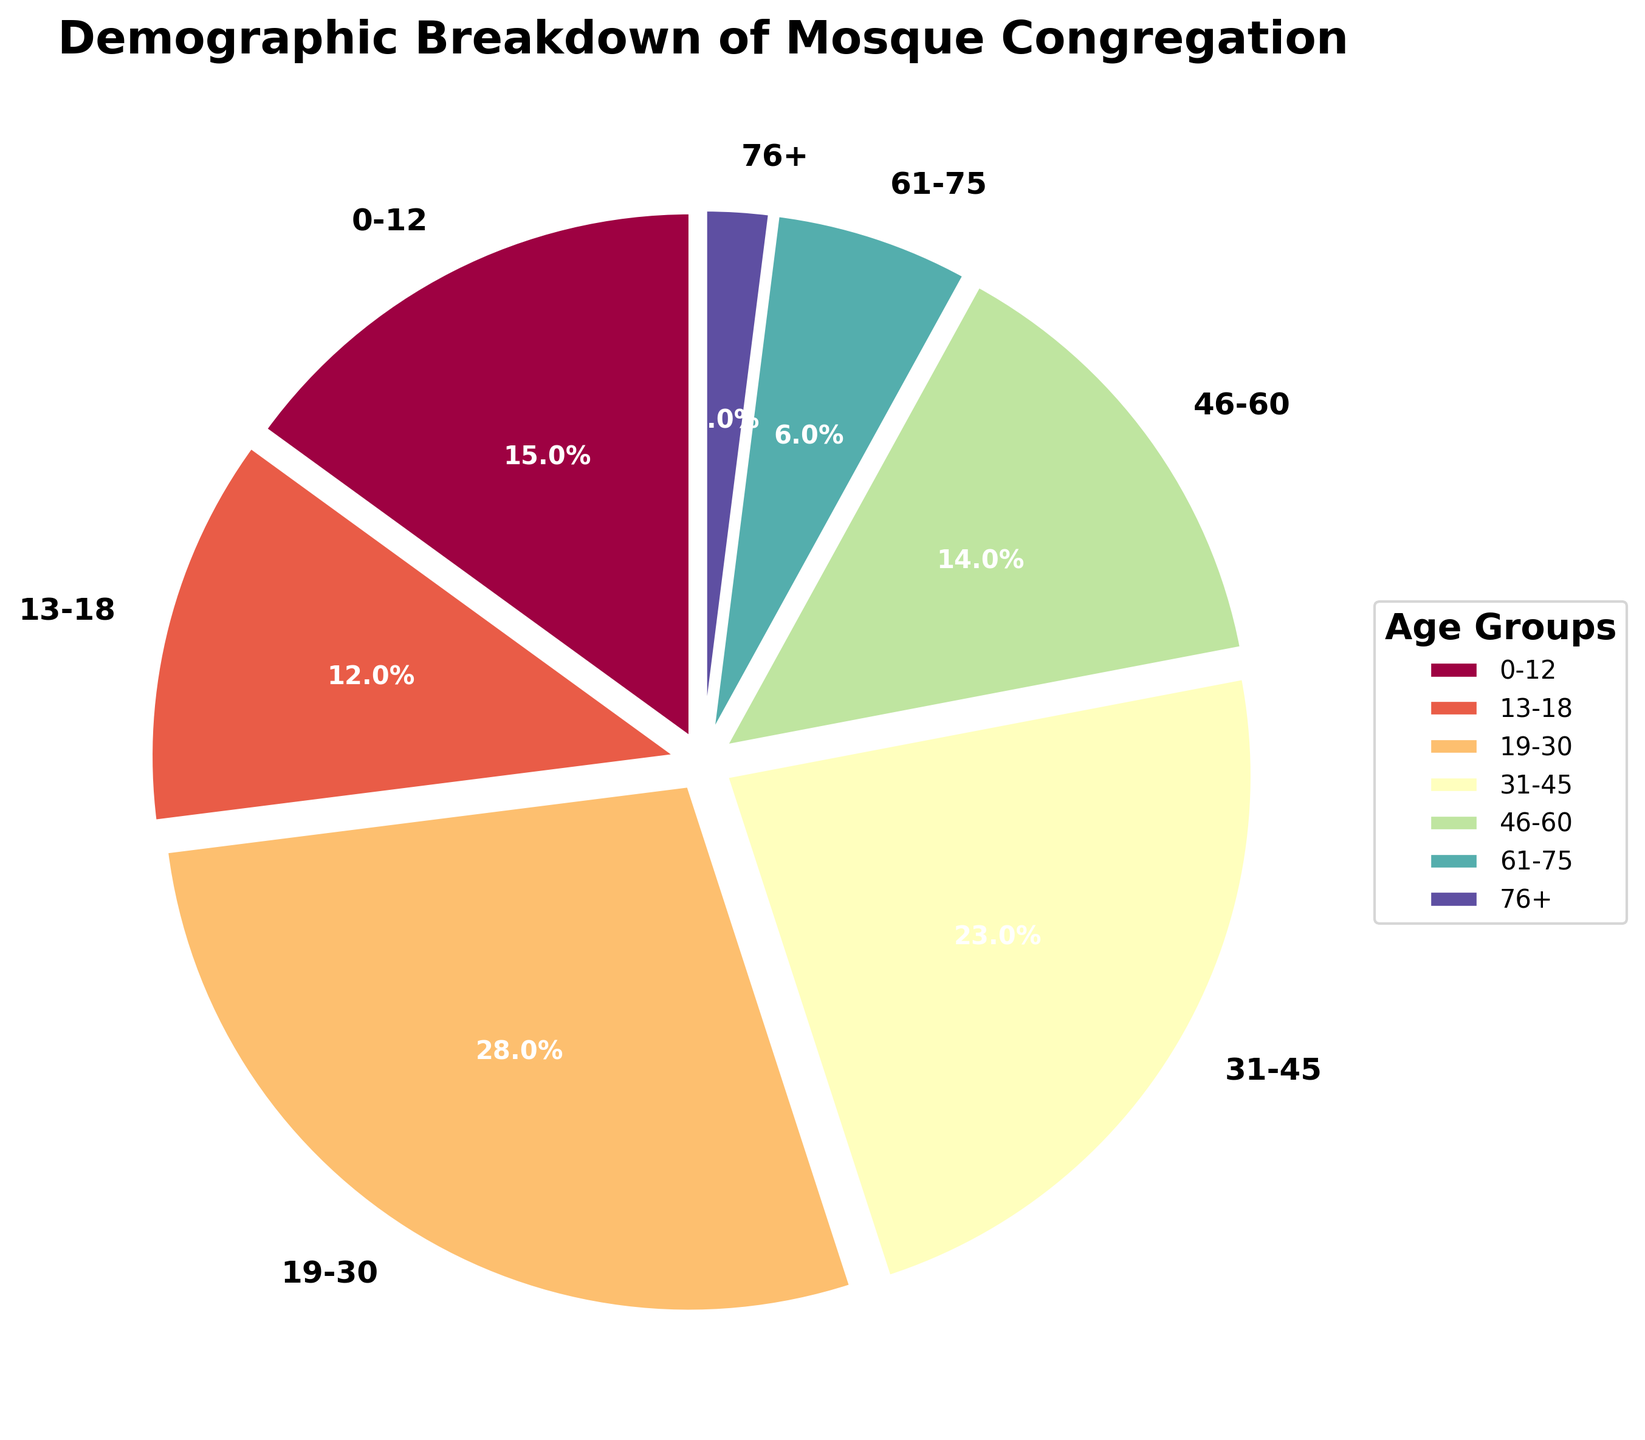How many age groups are represented in the mosque's congregation? There are 7 different age groups labeled on the pie chart: 0-12, 13-18, 19-30, 31-45, 46-60, 61-75, and 76+. This indicates that the congregation is divided into 7 distinct age categories.
Answer: 7 Which age group constitutes the largest percentage of the congregation? By observing the pie chart, the 19-30 age group has the largest segment, indicated by its size and the percentage label, 28%.
Answer: 19-30 What is the combined percentage of the youngest (0-12) and the oldest (76+) age groups? From the chart, the 0-12 age group is 15%, and the 76+ age group is 2%. Adding these together, we get 15% + 2% = 17%.
Answer: 17% Which age group has a larger percentage, 31-45 or 46-60? From the chart, the 31-45 age group has a percentage of 23%, while the 46-60 age group has 14%. Thus, the 31-45 age group has a larger percentage.
Answer: 31-45 How much larger is the percentage of the 19-30 age group compared to the 61-75 age group? The percentage for the 19-30 age group is 28%, and for the 61-75 age group, it is 6%. Subtracting these gives 28% - 6% = 22%.
Answer: 22% What is the total percentage of the congregation that is aged 13-45? The 13-18 age group is 12%, the 19-30 age group is 28%, and the 31-45 age group is 23%. Adding these together, we get 12% + 28% + 23% = 63%.
Answer: 63% Which age group has the smallest percentage? Observing the chart, the 76+ age group has the smallest segment, labeled as 2%.
Answer: 76+ Identify the color associated with the 0-12 age group in the pie chart. By looking at the pie chart, we can see that each segment is a different color. The 0-12 age group is represented by a particular color that is distinctly different from the others. The specific color should be provided based on the visual representation (e.g., "blue", "green").
Answer: [specific color] How much of the congregation is below 18 years old? Adding the percentages for the 0-12 and 13-18 age groups, we have 15% + 12% = 27%. Thus, 27% of the congregation is below 18 years old.
Answer: 27% Between the age groups 46-60 and 61-75, which group is colored more vibrantly? Visually assess the colors used on the pie chart. Vibrant colors are typically more intense or vivid. Based on the visual depiction, one of the two age groups should have a more vibrant color.
Answer: [specific age group with vivid color] 